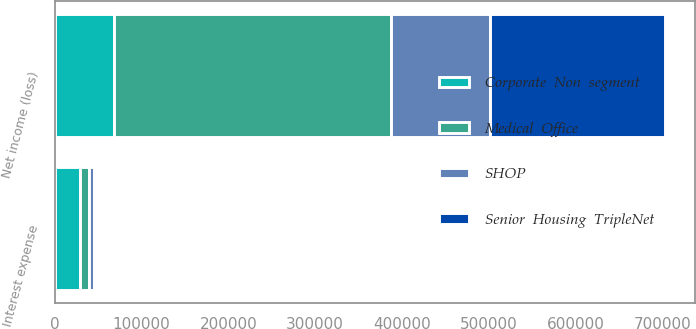Convert chart. <chart><loc_0><loc_0><loc_500><loc_500><stacked_bar_chart><ecel><fcel>Interest expense<fcel>Net income (loss)<nl><fcel>Medical  Office<fcel>9499<fcel>319507<nl><fcel>Corporate  Non  segment<fcel>29745<fcel>68076<nl><fcel>Senior  Housing  TripleNet<fcel>2357<fcel>201915<nl><fcel>SHOP<fcel>5895<fcel>113241<nl></chart> 